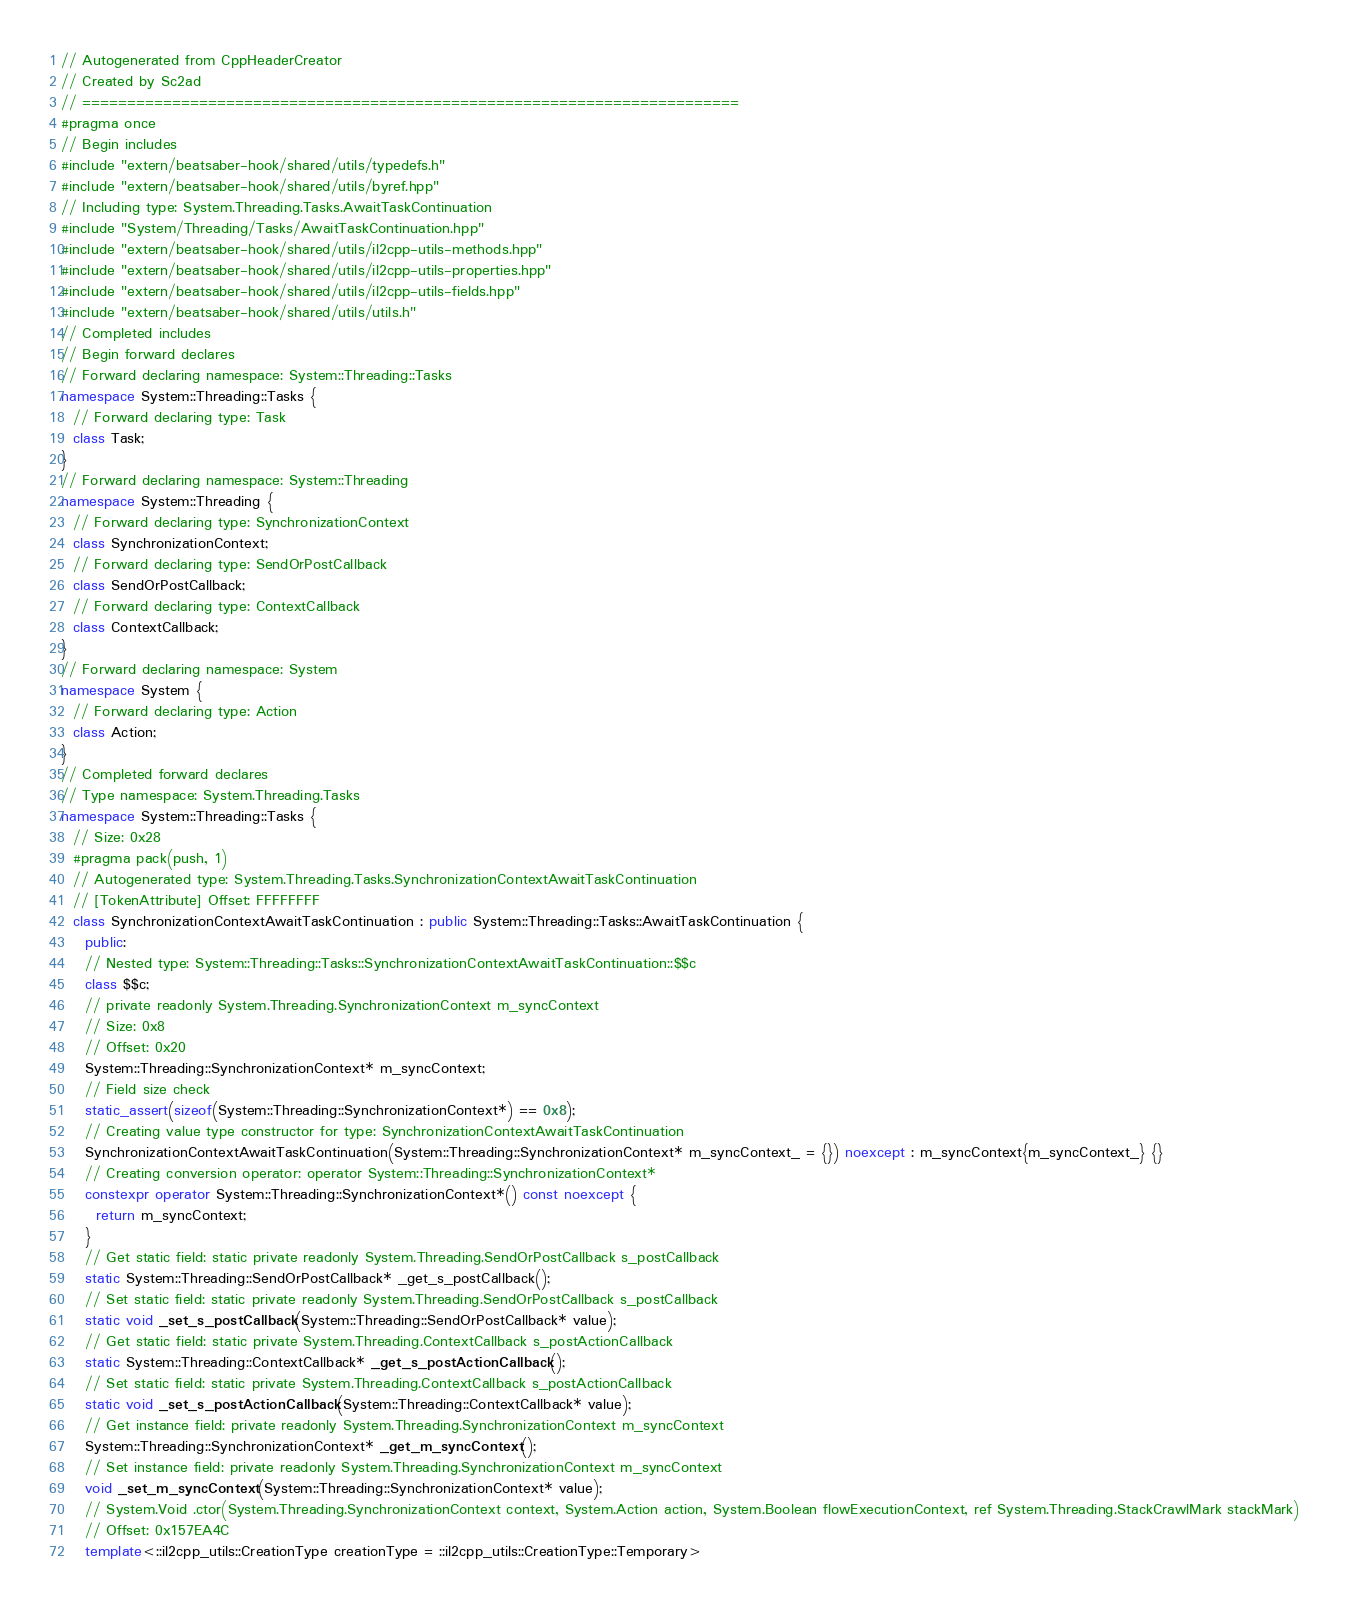Convert code to text. <code><loc_0><loc_0><loc_500><loc_500><_C++_>// Autogenerated from CppHeaderCreator
// Created by Sc2ad
// =========================================================================
#pragma once
// Begin includes
#include "extern/beatsaber-hook/shared/utils/typedefs.h"
#include "extern/beatsaber-hook/shared/utils/byref.hpp"
// Including type: System.Threading.Tasks.AwaitTaskContinuation
#include "System/Threading/Tasks/AwaitTaskContinuation.hpp"
#include "extern/beatsaber-hook/shared/utils/il2cpp-utils-methods.hpp"
#include "extern/beatsaber-hook/shared/utils/il2cpp-utils-properties.hpp"
#include "extern/beatsaber-hook/shared/utils/il2cpp-utils-fields.hpp"
#include "extern/beatsaber-hook/shared/utils/utils.h"
// Completed includes
// Begin forward declares
// Forward declaring namespace: System::Threading::Tasks
namespace System::Threading::Tasks {
  // Forward declaring type: Task
  class Task;
}
// Forward declaring namespace: System::Threading
namespace System::Threading {
  // Forward declaring type: SynchronizationContext
  class SynchronizationContext;
  // Forward declaring type: SendOrPostCallback
  class SendOrPostCallback;
  // Forward declaring type: ContextCallback
  class ContextCallback;
}
// Forward declaring namespace: System
namespace System {
  // Forward declaring type: Action
  class Action;
}
// Completed forward declares
// Type namespace: System.Threading.Tasks
namespace System::Threading::Tasks {
  // Size: 0x28
  #pragma pack(push, 1)
  // Autogenerated type: System.Threading.Tasks.SynchronizationContextAwaitTaskContinuation
  // [TokenAttribute] Offset: FFFFFFFF
  class SynchronizationContextAwaitTaskContinuation : public System::Threading::Tasks::AwaitTaskContinuation {
    public:
    // Nested type: System::Threading::Tasks::SynchronizationContextAwaitTaskContinuation::$$c
    class $$c;
    // private readonly System.Threading.SynchronizationContext m_syncContext
    // Size: 0x8
    // Offset: 0x20
    System::Threading::SynchronizationContext* m_syncContext;
    // Field size check
    static_assert(sizeof(System::Threading::SynchronizationContext*) == 0x8);
    // Creating value type constructor for type: SynchronizationContextAwaitTaskContinuation
    SynchronizationContextAwaitTaskContinuation(System::Threading::SynchronizationContext* m_syncContext_ = {}) noexcept : m_syncContext{m_syncContext_} {}
    // Creating conversion operator: operator System::Threading::SynchronizationContext*
    constexpr operator System::Threading::SynchronizationContext*() const noexcept {
      return m_syncContext;
    }
    // Get static field: static private readonly System.Threading.SendOrPostCallback s_postCallback
    static System::Threading::SendOrPostCallback* _get_s_postCallback();
    // Set static field: static private readonly System.Threading.SendOrPostCallback s_postCallback
    static void _set_s_postCallback(System::Threading::SendOrPostCallback* value);
    // Get static field: static private System.Threading.ContextCallback s_postActionCallback
    static System::Threading::ContextCallback* _get_s_postActionCallback();
    // Set static field: static private System.Threading.ContextCallback s_postActionCallback
    static void _set_s_postActionCallback(System::Threading::ContextCallback* value);
    // Get instance field: private readonly System.Threading.SynchronizationContext m_syncContext
    System::Threading::SynchronizationContext* _get_m_syncContext();
    // Set instance field: private readonly System.Threading.SynchronizationContext m_syncContext
    void _set_m_syncContext(System::Threading::SynchronizationContext* value);
    // System.Void .ctor(System.Threading.SynchronizationContext context, System.Action action, System.Boolean flowExecutionContext, ref System.Threading.StackCrawlMark stackMark)
    // Offset: 0x157EA4C
    template<::il2cpp_utils::CreationType creationType = ::il2cpp_utils::CreationType::Temporary></code> 